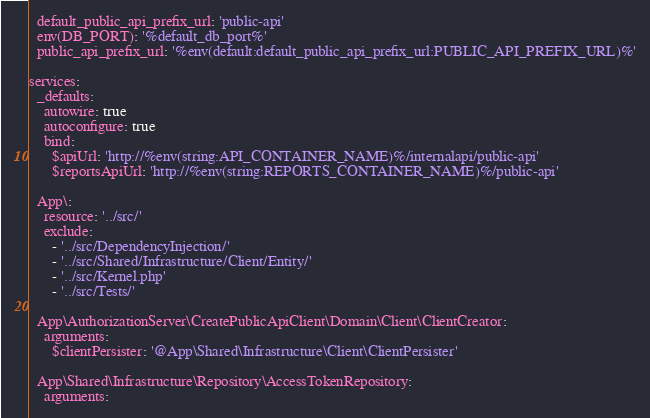Convert code to text. <code><loc_0><loc_0><loc_500><loc_500><_YAML_>  default_public_api_prefix_url: 'public-api'
  env(DB_PORT): '%default_db_port%'
  public_api_prefix_url: '%env(default:default_public_api_prefix_url:PUBLIC_API_PREFIX_URL)%'

services:
  _defaults:
    autowire: true
    autoconfigure: true
    bind:
      $apiUrl: 'http://%env(string:API_CONTAINER_NAME)%/internalapi/public-api'
      $reportsApiUrl: 'http://%env(string:REPORTS_CONTAINER_NAME)%/public-api'

  App\:
    resource: '../src/'
    exclude:
      - '../src/DependencyInjection/'
      - '../src/Shared/Infrastructure/Client/Entity/'
      - '../src/Kernel.php'
      - '../src/Tests/'

  App\AuthorizationServer\CreatePublicApiClient\Domain\Client\ClientCreator:
    arguments:
      $clientPersister: '@App\Shared\Infrastructure\Client\ClientPersister'

  App\Shared\Infrastructure\Repository\AccessTokenRepository:
    arguments:</code> 